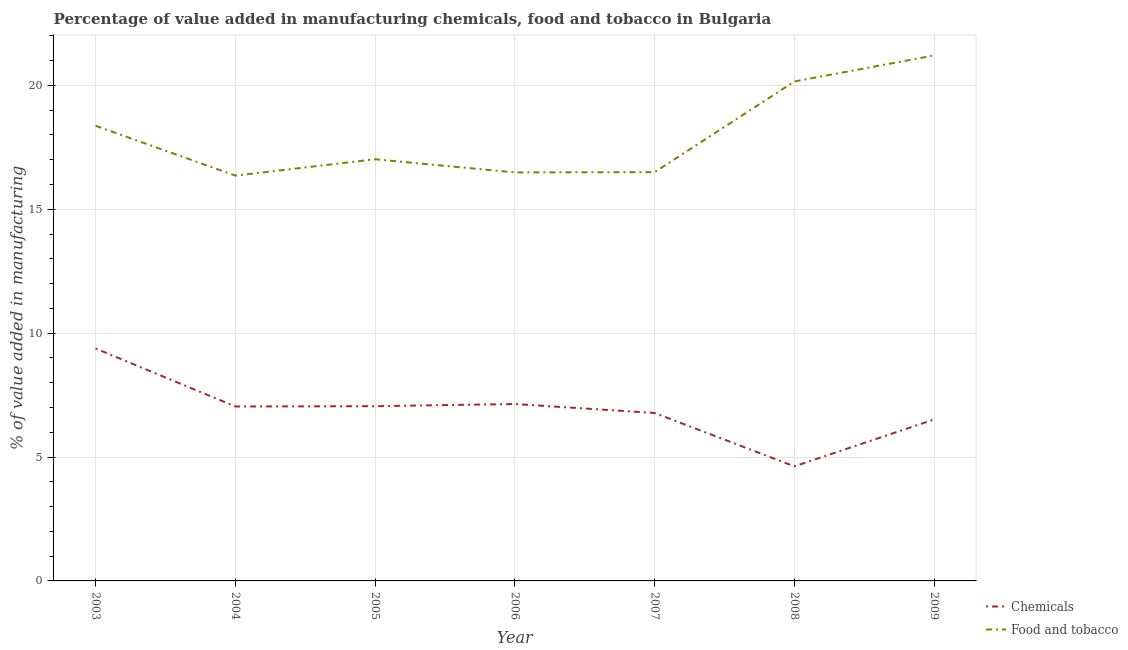Does the line corresponding to value added by manufacturing food and tobacco intersect with the line corresponding to value added by  manufacturing chemicals?
Keep it short and to the point. No. What is the value added by  manufacturing chemicals in 2005?
Provide a short and direct response. 7.05. Across all years, what is the maximum value added by manufacturing food and tobacco?
Your answer should be very brief. 21.21. Across all years, what is the minimum value added by manufacturing food and tobacco?
Make the answer very short. 16.36. What is the total value added by  manufacturing chemicals in the graph?
Your answer should be very brief. 48.53. What is the difference between the value added by manufacturing food and tobacco in 2007 and that in 2008?
Make the answer very short. -3.66. What is the difference between the value added by manufacturing food and tobacco in 2006 and the value added by  manufacturing chemicals in 2003?
Provide a succinct answer. 7.11. What is the average value added by  manufacturing chemicals per year?
Offer a terse response. 6.93. In the year 2003, what is the difference between the value added by  manufacturing chemicals and value added by manufacturing food and tobacco?
Give a very brief answer. -8.99. What is the ratio of the value added by  manufacturing chemicals in 2003 to that in 2007?
Give a very brief answer. 1.38. What is the difference between the highest and the second highest value added by  manufacturing chemicals?
Provide a short and direct response. 2.24. What is the difference between the highest and the lowest value added by  manufacturing chemicals?
Make the answer very short. 4.76. In how many years, is the value added by manufacturing food and tobacco greater than the average value added by manufacturing food and tobacco taken over all years?
Give a very brief answer. 3. Does the value added by manufacturing food and tobacco monotonically increase over the years?
Ensure brevity in your answer.  No. How many years are there in the graph?
Make the answer very short. 7. What is the difference between two consecutive major ticks on the Y-axis?
Your answer should be very brief. 5. How many legend labels are there?
Your response must be concise. 2. How are the legend labels stacked?
Offer a terse response. Vertical. What is the title of the graph?
Offer a terse response. Percentage of value added in manufacturing chemicals, food and tobacco in Bulgaria. What is the label or title of the X-axis?
Offer a very short reply. Year. What is the label or title of the Y-axis?
Keep it short and to the point. % of value added in manufacturing. What is the % of value added in manufacturing of Chemicals in 2003?
Keep it short and to the point. 9.38. What is the % of value added in manufacturing in Food and tobacco in 2003?
Offer a terse response. 18.37. What is the % of value added in manufacturing of Chemicals in 2004?
Give a very brief answer. 7.04. What is the % of value added in manufacturing in Food and tobacco in 2004?
Offer a terse response. 16.36. What is the % of value added in manufacturing in Chemicals in 2005?
Give a very brief answer. 7.05. What is the % of value added in manufacturing in Food and tobacco in 2005?
Your answer should be very brief. 17.02. What is the % of value added in manufacturing in Chemicals in 2006?
Your answer should be very brief. 7.14. What is the % of value added in manufacturing of Food and tobacco in 2006?
Keep it short and to the point. 16.49. What is the % of value added in manufacturing of Chemicals in 2007?
Provide a succinct answer. 6.78. What is the % of value added in manufacturing in Food and tobacco in 2007?
Your response must be concise. 16.5. What is the % of value added in manufacturing in Chemicals in 2008?
Ensure brevity in your answer.  4.62. What is the % of value added in manufacturing of Food and tobacco in 2008?
Ensure brevity in your answer.  20.16. What is the % of value added in manufacturing of Chemicals in 2009?
Offer a terse response. 6.52. What is the % of value added in manufacturing in Food and tobacco in 2009?
Provide a short and direct response. 21.21. Across all years, what is the maximum % of value added in manufacturing in Chemicals?
Make the answer very short. 9.38. Across all years, what is the maximum % of value added in manufacturing in Food and tobacco?
Keep it short and to the point. 21.21. Across all years, what is the minimum % of value added in manufacturing of Chemicals?
Your answer should be very brief. 4.62. Across all years, what is the minimum % of value added in manufacturing in Food and tobacco?
Keep it short and to the point. 16.36. What is the total % of value added in manufacturing of Chemicals in the graph?
Provide a succinct answer. 48.53. What is the total % of value added in manufacturing in Food and tobacco in the graph?
Make the answer very short. 126.09. What is the difference between the % of value added in manufacturing of Chemicals in 2003 and that in 2004?
Provide a succinct answer. 2.34. What is the difference between the % of value added in manufacturing in Food and tobacco in 2003 and that in 2004?
Provide a succinct answer. 2.01. What is the difference between the % of value added in manufacturing of Chemicals in 2003 and that in 2005?
Offer a terse response. 2.33. What is the difference between the % of value added in manufacturing in Food and tobacco in 2003 and that in 2005?
Provide a short and direct response. 1.35. What is the difference between the % of value added in manufacturing in Chemicals in 2003 and that in 2006?
Provide a short and direct response. 2.24. What is the difference between the % of value added in manufacturing of Food and tobacco in 2003 and that in 2006?
Your response must be concise. 1.88. What is the difference between the % of value added in manufacturing of Chemicals in 2003 and that in 2007?
Make the answer very short. 2.6. What is the difference between the % of value added in manufacturing of Food and tobacco in 2003 and that in 2007?
Offer a terse response. 1.87. What is the difference between the % of value added in manufacturing of Chemicals in 2003 and that in 2008?
Provide a short and direct response. 4.76. What is the difference between the % of value added in manufacturing in Food and tobacco in 2003 and that in 2008?
Give a very brief answer. -1.79. What is the difference between the % of value added in manufacturing of Chemicals in 2003 and that in 2009?
Your response must be concise. 2.86. What is the difference between the % of value added in manufacturing of Food and tobacco in 2003 and that in 2009?
Make the answer very short. -2.84. What is the difference between the % of value added in manufacturing in Chemicals in 2004 and that in 2005?
Keep it short and to the point. -0.01. What is the difference between the % of value added in manufacturing of Food and tobacco in 2004 and that in 2005?
Give a very brief answer. -0.66. What is the difference between the % of value added in manufacturing of Chemicals in 2004 and that in 2006?
Give a very brief answer. -0.1. What is the difference between the % of value added in manufacturing in Food and tobacco in 2004 and that in 2006?
Offer a terse response. -0.13. What is the difference between the % of value added in manufacturing of Chemicals in 2004 and that in 2007?
Your answer should be very brief. 0.26. What is the difference between the % of value added in manufacturing in Food and tobacco in 2004 and that in 2007?
Provide a short and direct response. -0.14. What is the difference between the % of value added in manufacturing of Chemicals in 2004 and that in 2008?
Give a very brief answer. 2.42. What is the difference between the % of value added in manufacturing of Food and tobacco in 2004 and that in 2008?
Offer a terse response. -3.8. What is the difference between the % of value added in manufacturing of Chemicals in 2004 and that in 2009?
Provide a short and direct response. 0.52. What is the difference between the % of value added in manufacturing of Food and tobacco in 2004 and that in 2009?
Offer a very short reply. -4.85. What is the difference between the % of value added in manufacturing of Chemicals in 2005 and that in 2006?
Your response must be concise. -0.09. What is the difference between the % of value added in manufacturing of Food and tobacco in 2005 and that in 2006?
Make the answer very short. 0.53. What is the difference between the % of value added in manufacturing in Chemicals in 2005 and that in 2007?
Offer a terse response. 0.27. What is the difference between the % of value added in manufacturing in Food and tobacco in 2005 and that in 2007?
Make the answer very short. 0.52. What is the difference between the % of value added in manufacturing of Chemicals in 2005 and that in 2008?
Offer a very short reply. 2.43. What is the difference between the % of value added in manufacturing of Food and tobacco in 2005 and that in 2008?
Make the answer very short. -3.14. What is the difference between the % of value added in manufacturing in Chemicals in 2005 and that in 2009?
Your response must be concise. 0.54. What is the difference between the % of value added in manufacturing in Food and tobacco in 2005 and that in 2009?
Your response must be concise. -4.19. What is the difference between the % of value added in manufacturing in Chemicals in 2006 and that in 2007?
Make the answer very short. 0.36. What is the difference between the % of value added in manufacturing in Food and tobacco in 2006 and that in 2007?
Your response must be concise. -0.01. What is the difference between the % of value added in manufacturing of Chemicals in 2006 and that in 2008?
Provide a succinct answer. 2.52. What is the difference between the % of value added in manufacturing in Food and tobacco in 2006 and that in 2008?
Provide a short and direct response. -3.67. What is the difference between the % of value added in manufacturing in Chemicals in 2006 and that in 2009?
Your answer should be compact. 0.62. What is the difference between the % of value added in manufacturing of Food and tobacco in 2006 and that in 2009?
Your answer should be compact. -4.72. What is the difference between the % of value added in manufacturing of Chemicals in 2007 and that in 2008?
Offer a terse response. 2.15. What is the difference between the % of value added in manufacturing of Food and tobacco in 2007 and that in 2008?
Provide a succinct answer. -3.66. What is the difference between the % of value added in manufacturing of Chemicals in 2007 and that in 2009?
Offer a terse response. 0.26. What is the difference between the % of value added in manufacturing in Food and tobacco in 2007 and that in 2009?
Give a very brief answer. -4.71. What is the difference between the % of value added in manufacturing of Chemicals in 2008 and that in 2009?
Ensure brevity in your answer.  -1.89. What is the difference between the % of value added in manufacturing in Food and tobacco in 2008 and that in 2009?
Offer a terse response. -1.05. What is the difference between the % of value added in manufacturing in Chemicals in 2003 and the % of value added in manufacturing in Food and tobacco in 2004?
Ensure brevity in your answer.  -6.98. What is the difference between the % of value added in manufacturing in Chemicals in 2003 and the % of value added in manufacturing in Food and tobacco in 2005?
Provide a short and direct response. -7.64. What is the difference between the % of value added in manufacturing of Chemicals in 2003 and the % of value added in manufacturing of Food and tobacco in 2006?
Keep it short and to the point. -7.11. What is the difference between the % of value added in manufacturing in Chemicals in 2003 and the % of value added in manufacturing in Food and tobacco in 2007?
Make the answer very short. -7.12. What is the difference between the % of value added in manufacturing of Chemicals in 2003 and the % of value added in manufacturing of Food and tobacco in 2008?
Provide a short and direct response. -10.78. What is the difference between the % of value added in manufacturing of Chemicals in 2003 and the % of value added in manufacturing of Food and tobacco in 2009?
Provide a short and direct response. -11.83. What is the difference between the % of value added in manufacturing of Chemicals in 2004 and the % of value added in manufacturing of Food and tobacco in 2005?
Make the answer very short. -9.98. What is the difference between the % of value added in manufacturing in Chemicals in 2004 and the % of value added in manufacturing in Food and tobacco in 2006?
Offer a terse response. -9.45. What is the difference between the % of value added in manufacturing of Chemicals in 2004 and the % of value added in manufacturing of Food and tobacco in 2007?
Make the answer very short. -9.46. What is the difference between the % of value added in manufacturing of Chemicals in 2004 and the % of value added in manufacturing of Food and tobacco in 2008?
Provide a short and direct response. -13.12. What is the difference between the % of value added in manufacturing of Chemicals in 2004 and the % of value added in manufacturing of Food and tobacco in 2009?
Offer a terse response. -14.17. What is the difference between the % of value added in manufacturing in Chemicals in 2005 and the % of value added in manufacturing in Food and tobacco in 2006?
Make the answer very short. -9.43. What is the difference between the % of value added in manufacturing of Chemicals in 2005 and the % of value added in manufacturing of Food and tobacco in 2007?
Keep it short and to the point. -9.45. What is the difference between the % of value added in manufacturing of Chemicals in 2005 and the % of value added in manufacturing of Food and tobacco in 2008?
Provide a succinct answer. -13.1. What is the difference between the % of value added in manufacturing in Chemicals in 2005 and the % of value added in manufacturing in Food and tobacco in 2009?
Ensure brevity in your answer.  -14.16. What is the difference between the % of value added in manufacturing in Chemicals in 2006 and the % of value added in manufacturing in Food and tobacco in 2007?
Your answer should be compact. -9.36. What is the difference between the % of value added in manufacturing of Chemicals in 2006 and the % of value added in manufacturing of Food and tobacco in 2008?
Make the answer very short. -13.02. What is the difference between the % of value added in manufacturing of Chemicals in 2006 and the % of value added in manufacturing of Food and tobacco in 2009?
Give a very brief answer. -14.07. What is the difference between the % of value added in manufacturing in Chemicals in 2007 and the % of value added in manufacturing in Food and tobacco in 2008?
Provide a short and direct response. -13.38. What is the difference between the % of value added in manufacturing in Chemicals in 2007 and the % of value added in manufacturing in Food and tobacco in 2009?
Ensure brevity in your answer.  -14.43. What is the difference between the % of value added in manufacturing of Chemicals in 2008 and the % of value added in manufacturing of Food and tobacco in 2009?
Offer a terse response. -16.58. What is the average % of value added in manufacturing in Chemicals per year?
Provide a short and direct response. 6.93. What is the average % of value added in manufacturing in Food and tobacco per year?
Offer a very short reply. 18.01. In the year 2003, what is the difference between the % of value added in manufacturing in Chemicals and % of value added in manufacturing in Food and tobacco?
Offer a terse response. -8.99. In the year 2004, what is the difference between the % of value added in manufacturing of Chemicals and % of value added in manufacturing of Food and tobacco?
Give a very brief answer. -9.32. In the year 2005, what is the difference between the % of value added in manufacturing of Chemicals and % of value added in manufacturing of Food and tobacco?
Ensure brevity in your answer.  -9.97. In the year 2006, what is the difference between the % of value added in manufacturing in Chemicals and % of value added in manufacturing in Food and tobacco?
Offer a very short reply. -9.35. In the year 2007, what is the difference between the % of value added in manufacturing of Chemicals and % of value added in manufacturing of Food and tobacco?
Give a very brief answer. -9.72. In the year 2008, what is the difference between the % of value added in manufacturing in Chemicals and % of value added in manufacturing in Food and tobacco?
Provide a short and direct response. -15.53. In the year 2009, what is the difference between the % of value added in manufacturing in Chemicals and % of value added in manufacturing in Food and tobacco?
Provide a short and direct response. -14.69. What is the ratio of the % of value added in manufacturing in Chemicals in 2003 to that in 2004?
Your response must be concise. 1.33. What is the ratio of the % of value added in manufacturing of Food and tobacco in 2003 to that in 2004?
Provide a short and direct response. 1.12. What is the ratio of the % of value added in manufacturing in Chemicals in 2003 to that in 2005?
Offer a terse response. 1.33. What is the ratio of the % of value added in manufacturing of Food and tobacco in 2003 to that in 2005?
Your answer should be very brief. 1.08. What is the ratio of the % of value added in manufacturing in Chemicals in 2003 to that in 2006?
Your answer should be compact. 1.31. What is the ratio of the % of value added in manufacturing in Food and tobacco in 2003 to that in 2006?
Your answer should be very brief. 1.11. What is the ratio of the % of value added in manufacturing in Chemicals in 2003 to that in 2007?
Provide a short and direct response. 1.38. What is the ratio of the % of value added in manufacturing in Food and tobacco in 2003 to that in 2007?
Your answer should be compact. 1.11. What is the ratio of the % of value added in manufacturing in Chemicals in 2003 to that in 2008?
Provide a short and direct response. 2.03. What is the ratio of the % of value added in manufacturing in Food and tobacco in 2003 to that in 2008?
Keep it short and to the point. 0.91. What is the ratio of the % of value added in manufacturing in Chemicals in 2003 to that in 2009?
Ensure brevity in your answer.  1.44. What is the ratio of the % of value added in manufacturing of Food and tobacco in 2003 to that in 2009?
Give a very brief answer. 0.87. What is the ratio of the % of value added in manufacturing of Food and tobacco in 2004 to that in 2005?
Your answer should be compact. 0.96. What is the ratio of the % of value added in manufacturing of Chemicals in 2004 to that in 2006?
Ensure brevity in your answer.  0.99. What is the ratio of the % of value added in manufacturing in Food and tobacco in 2004 to that in 2006?
Provide a short and direct response. 0.99. What is the ratio of the % of value added in manufacturing in Chemicals in 2004 to that in 2007?
Provide a succinct answer. 1.04. What is the ratio of the % of value added in manufacturing of Food and tobacco in 2004 to that in 2007?
Ensure brevity in your answer.  0.99. What is the ratio of the % of value added in manufacturing of Chemicals in 2004 to that in 2008?
Give a very brief answer. 1.52. What is the ratio of the % of value added in manufacturing in Food and tobacco in 2004 to that in 2008?
Offer a terse response. 0.81. What is the ratio of the % of value added in manufacturing of Chemicals in 2004 to that in 2009?
Provide a short and direct response. 1.08. What is the ratio of the % of value added in manufacturing of Food and tobacco in 2004 to that in 2009?
Provide a succinct answer. 0.77. What is the ratio of the % of value added in manufacturing in Chemicals in 2005 to that in 2006?
Provide a succinct answer. 0.99. What is the ratio of the % of value added in manufacturing in Food and tobacco in 2005 to that in 2006?
Make the answer very short. 1.03. What is the ratio of the % of value added in manufacturing in Chemicals in 2005 to that in 2007?
Make the answer very short. 1.04. What is the ratio of the % of value added in manufacturing of Food and tobacco in 2005 to that in 2007?
Your response must be concise. 1.03. What is the ratio of the % of value added in manufacturing of Chemicals in 2005 to that in 2008?
Offer a very short reply. 1.52. What is the ratio of the % of value added in manufacturing of Food and tobacco in 2005 to that in 2008?
Give a very brief answer. 0.84. What is the ratio of the % of value added in manufacturing of Chemicals in 2005 to that in 2009?
Your response must be concise. 1.08. What is the ratio of the % of value added in manufacturing of Food and tobacco in 2005 to that in 2009?
Offer a very short reply. 0.8. What is the ratio of the % of value added in manufacturing of Chemicals in 2006 to that in 2007?
Provide a short and direct response. 1.05. What is the ratio of the % of value added in manufacturing of Chemicals in 2006 to that in 2008?
Your answer should be very brief. 1.54. What is the ratio of the % of value added in manufacturing in Food and tobacco in 2006 to that in 2008?
Give a very brief answer. 0.82. What is the ratio of the % of value added in manufacturing of Chemicals in 2006 to that in 2009?
Make the answer very short. 1.1. What is the ratio of the % of value added in manufacturing in Food and tobacco in 2006 to that in 2009?
Offer a terse response. 0.78. What is the ratio of the % of value added in manufacturing of Chemicals in 2007 to that in 2008?
Offer a very short reply. 1.47. What is the ratio of the % of value added in manufacturing in Food and tobacco in 2007 to that in 2008?
Your response must be concise. 0.82. What is the ratio of the % of value added in manufacturing of Chemicals in 2007 to that in 2009?
Offer a very short reply. 1.04. What is the ratio of the % of value added in manufacturing in Food and tobacco in 2007 to that in 2009?
Keep it short and to the point. 0.78. What is the ratio of the % of value added in manufacturing in Chemicals in 2008 to that in 2009?
Make the answer very short. 0.71. What is the ratio of the % of value added in manufacturing in Food and tobacco in 2008 to that in 2009?
Keep it short and to the point. 0.95. What is the difference between the highest and the second highest % of value added in manufacturing of Chemicals?
Ensure brevity in your answer.  2.24. What is the difference between the highest and the second highest % of value added in manufacturing in Food and tobacco?
Ensure brevity in your answer.  1.05. What is the difference between the highest and the lowest % of value added in manufacturing in Chemicals?
Make the answer very short. 4.76. What is the difference between the highest and the lowest % of value added in manufacturing in Food and tobacco?
Your response must be concise. 4.85. 